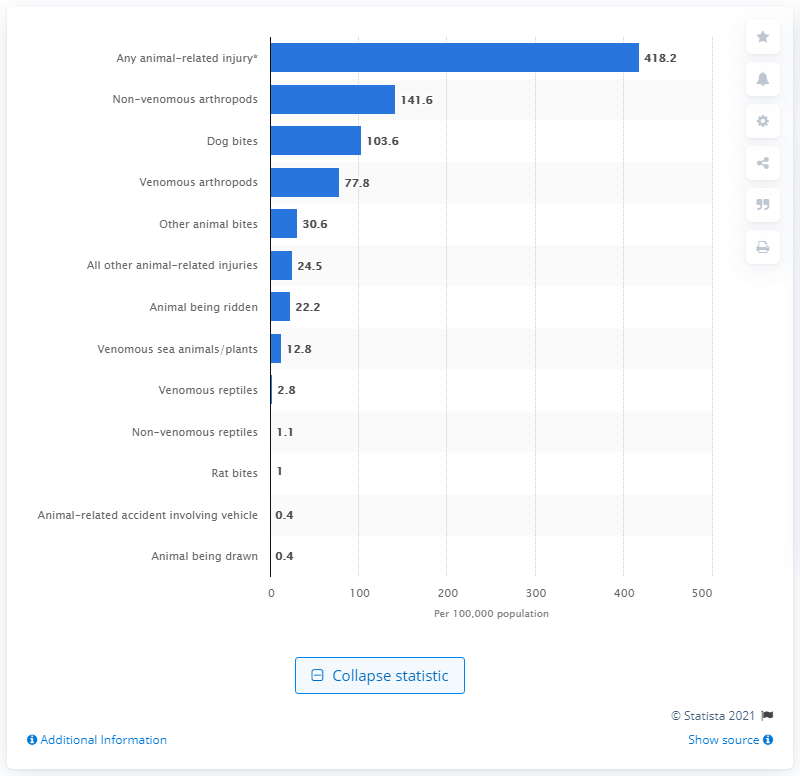Give some essential details in this illustration. In 2009, there were approximately 418.2 animal-related emergency department visits per 100,000 inhabitants in the United States. 